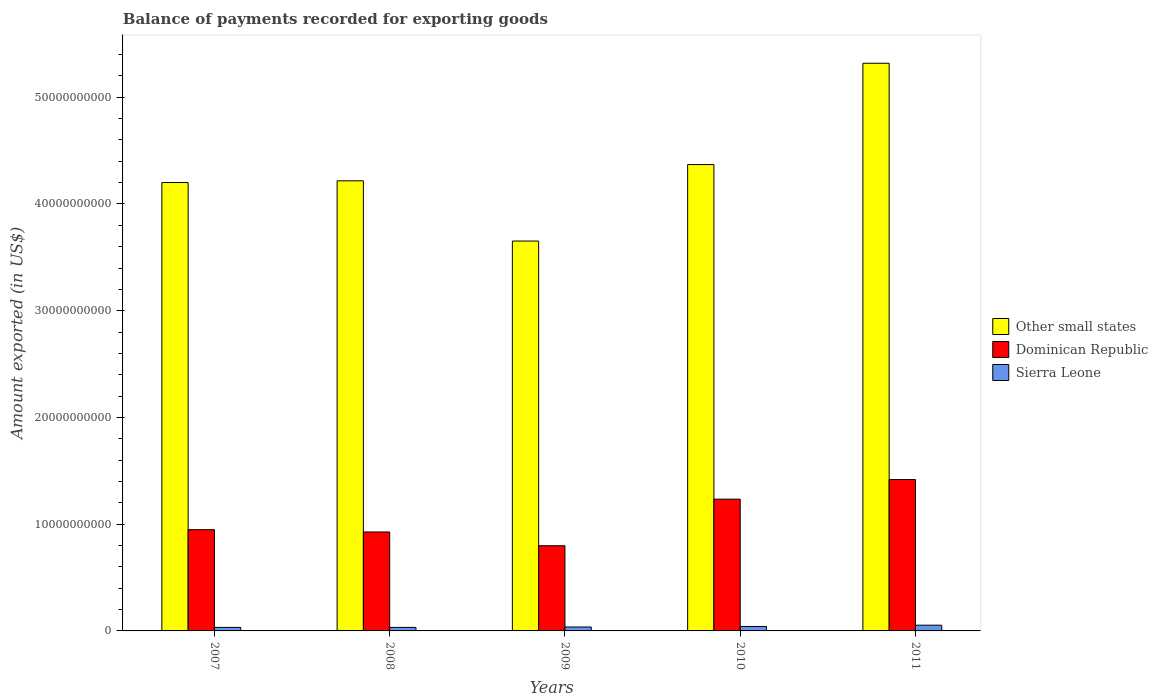How many groups of bars are there?
Give a very brief answer. 5. Are the number of bars per tick equal to the number of legend labels?
Your answer should be compact. Yes. How many bars are there on the 3rd tick from the left?
Provide a short and direct response. 3. What is the label of the 4th group of bars from the left?
Provide a succinct answer. 2010. In how many cases, is the number of bars for a given year not equal to the number of legend labels?
Provide a succinct answer. 0. What is the amount exported in Other small states in 2007?
Offer a very short reply. 4.20e+1. Across all years, what is the maximum amount exported in Dominican Republic?
Your answer should be compact. 1.42e+1. Across all years, what is the minimum amount exported in Other small states?
Your response must be concise. 3.65e+1. What is the total amount exported in Sierra Leone in the graph?
Provide a succinct answer. 1.98e+09. What is the difference between the amount exported in Other small states in 2007 and that in 2010?
Your response must be concise. -1.68e+09. What is the difference between the amount exported in Sierra Leone in 2008 and the amount exported in Other small states in 2009?
Your answer should be compact. -3.62e+1. What is the average amount exported in Dominican Republic per year?
Give a very brief answer. 1.07e+1. In the year 2010, what is the difference between the amount exported in Sierra Leone and amount exported in Dominican Republic?
Ensure brevity in your answer.  -1.19e+1. What is the ratio of the amount exported in Sierra Leone in 2007 to that in 2011?
Provide a short and direct response. 0.61. Is the amount exported in Dominican Republic in 2009 less than that in 2011?
Make the answer very short. Yes. Is the difference between the amount exported in Sierra Leone in 2007 and 2010 greater than the difference between the amount exported in Dominican Republic in 2007 and 2010?
Your answer should be very brief. Yes. What is the difference between the highest and the second highest amount exported in Other small states?
Your response must be concise. 9.49e+09. What is the difference between the highest and the lowest amount exported in Sierra Leone?
Make the answer very short. 2.08e+08. What does the 1st bar from the left in 2010 represents?
Make the answer very short. Other small states. What does the 1st bar from the right in 2008 represents?
Keep it short and to the point. Sierra Leone. Is it the case that in every year, the sum of the amount exported in Other small states and amount exported in Dominican Republic is greater than the amount exported in Sierra Leone?
Your answer should be compact. Yes. How many bars are there?
Make the answer very short. 15. How many years are there in the graph?
Keep it short and to the point. 5. What is the difference between two consecutive major ticks on the Y-axis?
Keep it short and to the point. 1.00e+1. Does the graph contain any zero values?
Your response must be concise. No. Does the graph contain grids?
Keep it short and to the point. No. Where does the legend appear in the graph?
Make the answer very short. Center right. How are the legend labels stacked?
Make the answer very short. Vertical. What is the title of the graph?
Make the answer very short. Balance of payments recorded for exporting goods. Does "Northern Mariana Islands" appear as one of the legend labels in the graph?
Your answer should be compact. No. What is the label or title of the Y-axis?
Keep it short and to the point. Amount exported (in US$). What is the Amount exported (in US$) in Other small states in 2007?
Keep it short and to the point. 4.20e+1. What is the Amount exported (in US$) in Dominican Republic in 2007?
Keep it short and to the point. 9.49e+09. What is the Amount exported (in US$) of Sierra Leone in 2007?
Make the answer very short. 3.31e+08. What is the Amount exported (in US$) of Other small states in 2008?
Keep it short and to the point. 4.22e+1. What is the Amount exported (in US$) in Dominican Republic in 2008?
Your answer should be very brief. 9.27e+09. What is the Amount exported (in US$) of Sierra Leone in 2008?
Your response must be concise. 3.30e+08. What is the Amount exported (in US$) in Other small states in 2009?
Offer a very short reply. 3.65e+1. What is the Amount exported (in US$) in Dominican Republic in 2009?
Your response must be concise. 7.98e+09. What is the Amount exported (in US$) of Sierra Leone in 2009?
Offer a very short reply. 3.68e+08. What is the Amount exported (in US$) in Other small states in 2010?
Your response must be concise. 4.37e+1. What is the Amount exported (in US$) of Dominican Republic in 2010?
Provide a short and direct response. 1.23e+1. What is the Amount exported (in US$) of Sierra Leone in 2010?
Ensure brevity in your answer.  4.17e+08. What is the Amount exported (in US$) of Other small states in 2011?
Offer a very short reply. 5.32e+1. What is the Amount exported (in US$) in Dominican Republic in 2011?
Provide a short and direct response. 1.42e+1. What is the Amount exported (in US$) in Sierra Leone in 2011?
Offer a very short reply. 5.38e+08. Across all years, what is the maximum Amount exported (in US$) in Other small states?
Provide a succinct answer. 5.32e+1. Across all years, what is the maximum Amount exported (in US$) of Dominican Republic?
Your response must be concise. 1.42e+1. Across all years, what is the maximum Amount exported (in US$) in Sierra Leone?
Your response must be concise. 5.38e+08. Across all years, what is the minimum Amount exported (in US$) of Other small states?
Your answer should be compact. 3.65e+1. Across all years, what is the minimum Amount exported (in US$) of Dominican Republic?
Your answer should be very brief. 7.98e+09. Across all years, what is the minimum Amount exported (in US$) in Sierra Leone?
Give a very brief answer. 3.30e+08. What is the total Amount exported (in US$) in Other small states in the graph?
Keep it short and to the point. 2.18e+11. What is the total Amount exported (in US$) of Dominican Republic in the graph?
Your response must be concise. 5.33e+1. What is the total Amount exported (in US$) in Sierra Leone in the graph?
Your response must be concise. 1.98e+09. What is the difference between the Amount exported (in US$) in Other small states in 2007 and that in 2008?
Your answer should be very brief. -1.59e+08. What is the difference between the Amount exported (in US$) of Dominican Republic in 2007 and that in 2008?
Offer a very short reply. 2.16e+08. What is the difference between the Amount exported (in US$) of Sierra Leone in 2007 and that in 2008?
Keep it short and to the point. 5.84e+04. What is the difference between the Amount exported (in US$) of Other small states in 2007 and that in 2009?
Ensure brevity in your answer.  5.48e+09. What is the difference between the Amount exported (in US$) of Dominican Republic in 2007 and that in 2009?
Keep it short and to the point. 1.50e+09. What is the difference between the Amount exported (in US$) in Sierra Leone in 2007 and that in 2009?
Make the answer very short. -3.78e+07. What is the difference between the Amount exported (in US$) of Other small states in 2007 and that in 2010?
Provide a succinct answer. -1.68e+09. What is the difference between the Amount exported (in US$) in Dominican Republic in 2007 and that in 2010?
Your response must be concise. -2.86e+09. What is the difference between the Amount exported (in US$) of Sierra Leone in 2007 and that in 2010?
Keep it short and to the point. -8.63e+07. What is the difference between the Amount exported (in US$) of Other small states in 2007 and that in 2011?
Provide a short and direct response. -1.12e+1. What is the difference between the Amount exported (in US$) in Dominican Republic in 2007 and that in 2011?
Your answer should be very brief. -4.70e+09. What is the difference between the Amount exported (in US$) of Sierra Leone in 2007 and that in 2011?
Your response must be concise. -2.08e+08. What is the difference between the Amount exported (in US$) of Other small states in 2008 and that in 2009?
Ensure brevity in your answer.  5.64e+09. What is the difference between the Amount exported (in US$) of Dominican Republic in 2008 and that in 2009?
Offer a very short reply. 1.29e+09. What is the difference between the Amount exported (in US$) in Sierra Leone in 2008 and that in 2009?
Ensure brevity in your answer.  -3.79e+07. What is the difference between the Amount exported (in US$) of Other small states in 2008 and that in 2010?
Your response must be concise. -1.52e+09. What is the difference between the Amount exported (in US$) in Dominican Republic in 2008 and that in 2010?
Give a very brief answer. -3.08e+09. What is the difference between the Amount exported (in US$) of Sierra Leone in 2008 and that in 2010?
Offer a terse response. -8.64e+07. What is the difference between the Amount exported (in US$) of Other small states in 2008 and that in 2011?
Your response must be concise. -1.10e+1. What is the difference between the Amount exported (in US$) of Dominican Republic in 2008 and that in 2011?
Ensure brevity in your answer.  -4.91e+09. What is the difference between the Amount exported (in US$) in Sierra Leone in 2008 and that in 2011?
Provide a succinct answer. -2.08e+08. What is the difference between the Amount exported (in US$) of Other small states in 2009 and that in 2010?
Your response must be concise. -7.16e+09. What is the difference between the Amount exported (in US$) in Dominican Republic in 2009 and that in 2010?
Keep it short and to the point. -4.36e+09. What is the difference between the Amount exported (in US$) of Sierra Leone in 2009 and that in 2010?
Offer a terse response. -4.86e+07. What is the difference between the Amount exported (in US$) of Other small states in 2009 and that in 2011?
Provide a short and direct response. -1.67e+1. What is the difference between the Amount exported (in US$) of Dominican Republic in 2009 and that in 2011?
Provide a succinct answer. -6.20e+09. What is the difference between the Amount exported (in US$) in Sierra Leone in 2009 and that in 2011?
Keep it short and to the point. -1.70e+08. What is the difference between the Amount exported (in US$) of Other small states in 2010 and that in 2011?
Make the answer very short. -9.49e+09. What is the difference between the Amount exported (in US$) of Dominican Republic in 2010 and that in 2011?
Make the answer very short. -1.84e+09. What is the difference between the Amount exported (in US$) in Sierra Leone in 2010 and that in 2011?
Offer a terse response. -1.21e+08. What is the difference between the Amount exported (in US$) of Other small states in 2007 and the Amount exported (in US$) of Dominican Republic in 2008?
Give a very brief answer. 3.27e+1. What is the difference between the Amount exported (in US$) of Other small states in 2007 and the Amount exported (in US$) of Sierra Leone in 2008?
Provide a short and direct response. 4.17e+1. What is the difference between the Amount exported (in US$) in Dominican Republic in 2007 and the Amount exported (in US$) in Sierra Leone in 2008?
Your answer should be very brief. 9.15e+09. What is the difference between the Amount exported (in US$) in Other small states in 2007 and the Amount exported (in US$) in Dominican Republic in 2009?
Your response must be concise. 3.40e+1. What is the difference between the Amount exported (in US$) of Other small states in 2007 and the Amount exported (in US$) of Sierra Leone in 2009?
Your response must be concise. 4.16e+1. What is the difference between the Amount exported (in US$) in Dominican Republic in 2007 and the Amount exported (in US$) in Sierra Leone in 2009?
Provide a succinct answer. 9.12e+09. What is the difference between the Amount exported (in US$) in Other small states in 2007 and the Amount exported (in US$) in Dominican Republic in 2010?
Give a very brief answer. 2.97e+1. What is the difference between the Amount exported (in US$) of Other small states in 2007 and the Amount exported (in US$) of Sierra Leone in 2010?
Offer a terse response. 4.16e+1. What is the difference between the Amount exported (in US$) of Dominican Republic in 2007 and the Amount exported (in US$) of Sierra Leone in 2010?
Give a very brief answer. 9.07e+09. What is the difference between the Amount exported (in US$) of Other small states in 2007 and the Amount exported (in US$) of Dominican Republic in 2011?
Keep it short and to the point. 2.78e+1. What is the difference between the Amount exported (in US$) in Other small states in 2007 and the Amount exported (in US$) in Sierra Leone in 2011?
Provide a short and direct response. 4.15e+1. What is the difference between the Amount exported (in US$) of Dominican Republic in 2007 and the Amount exported (in US$) of Sierra Leone in 2011?
Your answer should be very brief. 8.95e+09. What is the difference between the Amount exported (in US$) in Other small states in 2008 and the Amount exported (in US$) in Dominican Republic in 2009?
Ensure brevity in your answer.  3.42e+1. What is the difference between the Amount exported (in US$) of Other small states in 2008 and the Amount exported (in US$) of Sierra Leone in 2009?
Provide a short and direct response. 4.18e+1. What is the difference between the Amount exported (in US$) of Dominican Republic in 2008 and the Amount exported (in US$) of Sierra Leone in 2009?
Provide a short and direct response. 8.90e+09. What is the difference between the Amount exported (in US$) in Other small states in 2008 and the Amount exported (in US$) in Dominican Republic in 2010?
Give a very brief answer. 2.98e+1. What is the difference between the Amount exported (in US$) in Other small states in 2008 and the Amount exported (in US$) in Sierra Leone in 2010?
Keep it short and to the point. 4.18e+1. What is the difference between the Amount exported (in US$) in Dominican Republic in 2008 and the Amount exported (in US$) in Sierra Leone in 2010?
Your answer should be compact. 8.85e+09. What is the difference between the Amount exported (in US$) of Other small states in 2008 and the Amount exported (in US$) of Dominican Republic in 2011?
Provide a succinct answer. 2.80e+1. What is the difference between the Amount exported (in US$) of Other small states in 2008 and the Amount exported (in US$) of Sierra Leone in 2011?
Offer a very short reply. 4.16e+1. What is the difference between the Amount exported (in US$) in Dominican Republic in 2008 and the Amount exported (in US$) in Sierra Leone in 2011?
Make the answer very short. 8.73e+09. What is the difference between the Amount exported (in US$) of Other small states in 2009 and the Amount exported (in US$) of Dominican Republic in 2010?
Your response must be concise. 2.42e+1. What is the difference between the Amount exported (in US$) in Other small states in 2009 and the Amount exported (in US$) in Sierra Leone in 2010?
Your answer should be compact. 3.61e+1. What is the difference between the Amount exported (in US$) in Dominican Republic in 2009 and the Amount exported (in US$) in Sierra Leone in 2010?
Provide a succinct answer. 7.57e+09. What is the difference between the Amount exported (in US$) in Other small states in 2009 and the Amount exported (in US$) in Dominican Republic in 2011?
Give a very brief answer. 2.23e+1. What is the difference between the Amount exported (in US$) of Other small states in 2009 and the Amount exported (in US$) of Sierra Leone in 2011?
Provide a short and direct response. 3.60e+1. What is the difference between the Amount exported (in US$) of Dominican Republic in 2009 and the Amount exported (in US$) of Sierra Leone in 2011?
Make the answer very short. 7.44e+09. What is the difference between the Amount exported (in US$) of Other small states in 2010 and the Amount exported (in US$) of Dominican Republic in 2011?
Offer a very short reply. 2.95e+1. What is the difference between the Amount exported (in US$) of Other small states in 2010 and the Amount exported (in US$) of Sierra Leone in 2011?
Give a very brief answer. 4.32e+1. What is the difference between the Amount exported (in US$) in Dominican Republic in 2010 and the Amount exported (in US$) in Sierra Leone in 2011?
Offer a terse response. 1.18e+1. What is the average Amount exported (in US$) of Other small states per year?
Your response must be concise. 4.35e+1. What is the average Amount exported (in US$) of Dominican Republic per year?
Ensure brevity in your answer.  1.07e+1. What is the average Amount exported (in US$) in Sierra Leone per year?
Offer a terse response. 3.97e+08. In the year 2007, what is the difference between the Amount exported (in US$) of Other small states and Amount exported (in US$) of Dominican Republic?
Provide a succinct answer. 3.25e+1. In the year 2007, what is the difference between the Amount exported (in US$) in Other small states and Amount exported (in US$) in Sierra Leone?
Your response must be concise. 4.17e+1. In the year 2007, what is the difference between the Amount exported (in US$) in Dominican Republic and Amount exported (in US$) in Sierra Leone?
Offer a very short reply. 9.15e+09. In the year 2008, what is the difference between the Amount exported (in US$) in Other small states and Amount exported (in US$) in Dominican Republic?
Give a very brief answer. 3.29e+1. In the year 2008, what is the difference between the Amount exported (in US$) of Other small states and Amount exported (in US$) of Sierra Leone?
Your answer should be compact. 4.18e+1. In the year 2008, what is the difference between the Amount exported (in US$) of Dominican Republic and Amount exported (in US$) of Sierra Leone?
Give a very brief answer. 8.94e+09. In the year 2009, what is the difference between the Amount exported (in US$) of Other small states and Amount exported (in US$) of Dominican Republic?
Keep it short and to the point. 2.85e+1. In the year 2009, what is the difference between the Amount exported (in US$) in Other small states and Amount exported (in US$) in Sierra Leone?
Give a very brief answer. 3.62e+1. In the year 2009, what is the difference between the Amount exported (in US$) in Dominican Republic and Amount exported (in US$) in Sierra Leone?
Offer a very short reply. 7.61e+09. In the year 2010, what is the difference between the Amount exported (in US$) of Other small states and Amount exported (in US$) of Dominican Republic?
Your answer should be compact. 3.13e+1. In the year 2010, what is the difference between the Amount exported (in US$) in Other small states and Amount exported (in US$) in Sierra Leone?
Offer a terse response. 4.33e+1. In the year 2010, what is the difference between the Amount exported (in US$) of Dominican Republic and Amount exported (in US$) of Sierra Leone?
Your answer should be compact. 1.19e+1. In the year 2011, what is the difference between the Amount exported (in US$) in Other small states and Amount exported (in US$) in Dominican Republic?
Provide a succinct answer. 3.90e+1. In the year 2011, what is the difference between the Amount exported (in US$) of Other small states and Amount exported (in US$) of Sierra Leone?
Your response must be concise. 5.26e+1. In the year 2011, what is the difference between the Amount exported (in US$) of Dominican Republic and Amount exported (in US$) of Sierra Leone?
Offer a very short reply. 1.36e+1. What is the ratio of the Amount exported (in US$) of Other small states in 2007 to that in 2008?
Your response must be concise. 1. What is the ratio of the Amount exported (in US$) of Dominican Republic in 2007 to that in 2008?
Offer a terse response. 1.02. What is the ratio of the Amount exported (in US$) in Other small states in 2007 to that in 2009?
Keep it short and to the point. 1.15. What is the ratio of the Amount exported (in US$) of Dominican Republic in 2007 to that in 2009?
Provide a succinct answer. 1.19. What is the ratio of the Amount exported (in US$) in Sierra Leone in 2007 to that in 2009?
Offer a terse response. 0.9. What is the ratio of the Amount exported (in US$) of Other small states in 2007 to that in 2010?
Your answer should be compact. 0.96. What is the ratio of the Amount exported (in US$) of Dominican Republic in 2007 to that in 2010?
Your answer should be very brief. 0.77. What is the ratio of the Amount exported (in US$) in Sierra Leone in 2007 to that in 2010?
Your answer should be very brief. 0.79. What is the ratio of the Amount exported (in US$) in Other small states in 2007 to that in 2011?
Your answer should be very brief. 0.79. What is the ratio of the Amount exported (in US$) in Dominican Republic in 2007 to that in 2011?
Provide a succinct answer. 0.67. What is the ratio of the Amount exported (in US$) in Sierra Leone in 2007 to that in 2011?
Ensure brevity in your answer.  0.61. What is the ratio of the Amount exported (in US$) of Other small states in 2008 to that in 2009?
Keep it short and to the point. 1.15. What is the ratio of the Amount exported (in US$) of Dominican Republic in 2008 to that in 2009?
Your response must be concise. 1.16. What is the ratio of the Amount exported (in US$) of Sierra Leone in 2008 to that in 2009?
Ensure brevity in your answer.  0.9. What is the ratio of the Amount exported (in US$) in Other small states in 2008 to that in 2010?
Your answer should be compact. 0.97. What is the ratio of the Amount exported (in US$) in Dominican Republic in 2008 to that in 2010?
Provide a succinct answer. 0.75. What is the ratio of the Amount exported (in US$) in Sierra Leone in 2008 to that in 2010?
Your answer should be very brief. 0.79. What is the ratio of the Amount exported (in US$) of Other small states in 2008 to that in 2011?
Your response must be concise. 0.79. What is the ratio of the Amount exported (in US$) in Dominican Republic in 2008 to that in 2011?
Give a very brief answer. 0.65. What is the ratio of the Amount exported (in US$) of Sierra Leone in 2008 to that in 2011?
Offer a terse response. 0.61. What is the ratio of the Amount exported (in US$) of Other small states in 2009 to that in 2010?
Your answer should be very brief. 0.84. What is the ratio of the Amount exported (in US$) of Dominican Republic in 2009 to that in 2010?
Make the answer very short. 0.65. What is the ratio of the Amount exported (in US$) in Sierra Leone in 2009 to that in 2010?
Keep it short and to the point. 0.88. What is the ratio of the Amount exported (in US$) in Other small states in 2009 to that in 2011?
Your answer should be very brief. 0.69. What is the ratio of the Amount exported (in US$) of Dominican Republic in 2009 to that in 2011?
Your answer should be compact. 0.56. What is the ratio of the Amount exported (in US$) in Sierra Leone in 2009 to that in 2011?
Give a very brief answer. 0.68. What is the ratio of the Amount exported (in US$) in Other small states in 2010 to that in 2011?
Your answer should be very brief. 0.82. What is the ratio of the Amount exported (in US$) in Dominican Republic in 2010 to that in 2011?
Keep it short and to the point. 0.87. What is the ratio of the Amount exported (in US$) in Sierra Leone in 2010 to that in 2011?
Your answer should be compact. 0.77. What is the difference between the highest and the second highest Amount exported (in US$) of Other small states?
Give a very brief answer. 9.49e+09. What is the difference between the highest and the second highest Amount exported (in US$) in Dominican Republic?
Your answer should be very brief. 1.84e+09. What is the difference between the highest and the second highest Amount exported (in US$) of Sierra Leone?
Provide a succinct answer. 1.21e+08. What is the difference between the highest and the lowest Amount exported (in US$) of Other small states?
Your answer should be very brief. 1.67e+1. What is the difference between the highest and the lowest Amount exported (in US$) of Dominican Republic?
Give a very brief answer. 6.20e+09. What is the difference between the highest and the lowest Amount exported (in US$) of Sierra Leone?
Provide a succinct answer. 2.08e+08. 